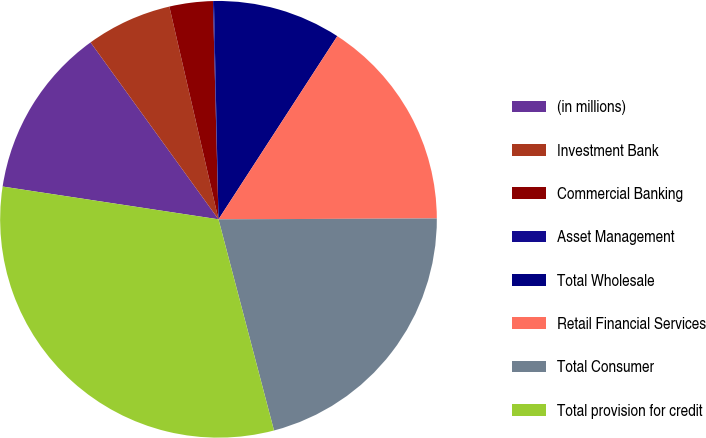Convert chart to OTSL. <chart><loc_0><loc_0><loc_500><loc_500><pie_chart><fcel>(in millions)<fcel>Investment Bank<fcel>Commercial Banking<fcel>Asset Management<fcel>Total Wholesale<fcel>Retail Financial Services<fcel>Total Consumer<fcel>Total provision for credit<nl><fcel>12.64%<fcel>6.35%<fcel>3.21%<fcel>0.07%<fcel>9.49%<fcel>15.78%<fcel>20.97%<fcel>31.49%<nl></chart> 